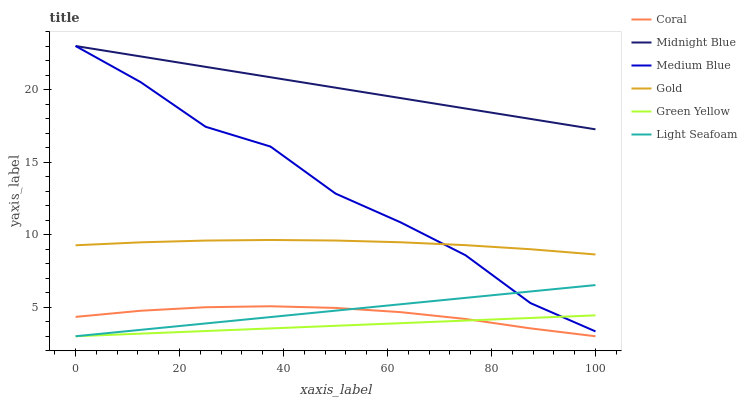Does Green Yellow have the minimum area under the curve?
Answer yes or no. Yes. Does Midnight Blue have the maximum area under the curve?
Answer yes or no. Yes. Does Gold have the minimum area under the curve?
Answer yes or no. No. Does Gold have the maximum area under the curve?
Answer yes or no. No. Is Green Yellow the smoothest?
Answer yes or no. Yes. Is Medium Blue the roughest?
Answer yes or no. Yes. Is Midnight Blue the smoothest?
Answer yes or no. No. Is Midnight Blue the roughest?
Answer yes or no. No. Does Green Yellow have the lowest value?
Answer yes or no. Yes. Does Gold have the lowest value?
Answer yes or no. No. Does Medium Blue have the highest value?
Answer yes or no. Yes. Does Gold have the highest value?
Answer yes or no. No. Is Gold less than Midnight Blue?
Answer yes or no. Yes. Is Midnight Blue greater than Green Yellow?
Answer yes or no. Yes. Does Medium Blue intersect Midnight Blue?
Answer yes or no. Yes. Is Medium Blue less than Midnight Blue?
Answer yes or no. No. Is Medium Blue greater than Midnight Blue?
Answer yes or no. No. Does Gold intersect Midnight Blue?
Answer yes or no. No. 